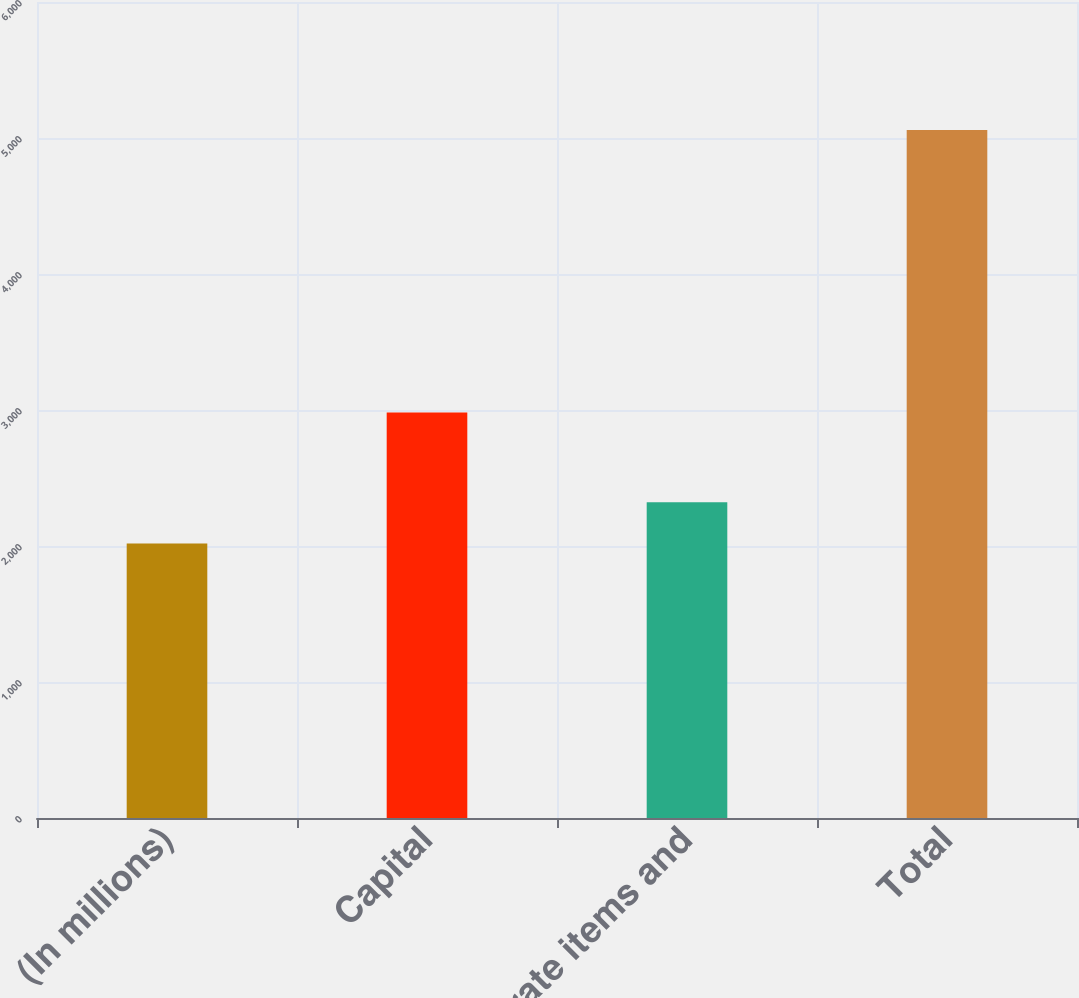<chart> <loc_0><loc_0><loc_500><loc_500><bar_chart><fcel>(In millions)<fcel>Capital<fcel>Corporate items and<fcel>Total<nl><fcel>2018<fcel>2982<fcel>2322.1<fcel>5059<nl></chart> 